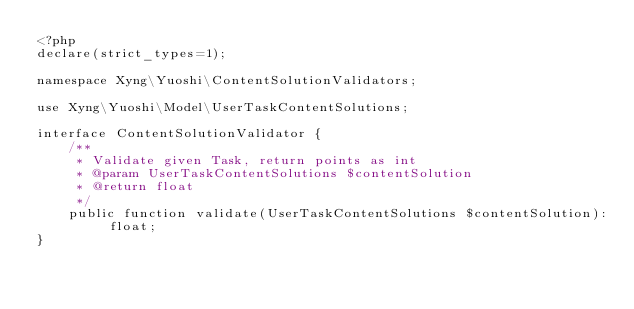Convert code to text. <code><loc_0><loc_0><loc_500><loc_500><_PHP_><?php
declare(strict_types=1);

namespace Xyng\Yuoshi\ContentSolutionValidators;

use Xyng\Yuoshi\Model\UserTaskContentSolutions;

interface ContentSolutionValidator {
    /**
     * Validate given Task, return points as int
     * @param UserTaskContentSolutions $contentSolution
     * @return float
     */
    public function validate(UserTaskContentSolutions $contentSolution): float;
}
</code> 